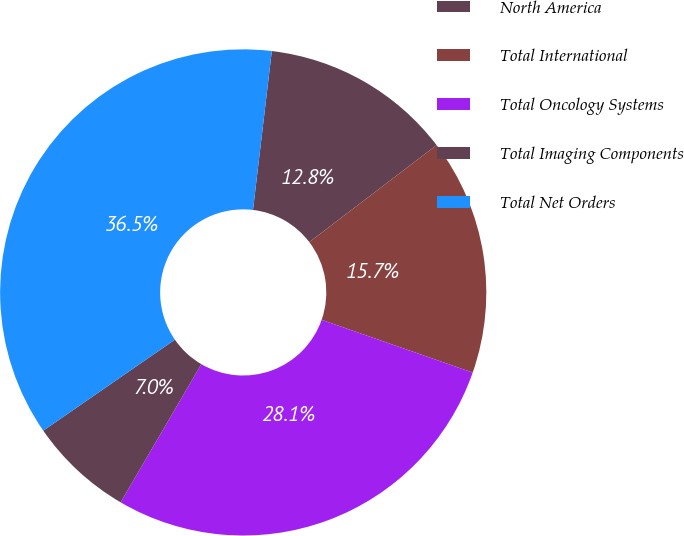<chart> <loc_0><loc_0><loc_500><loc_500><pie_chart><fcel>North America<fcel>Total International<fcel>Total Oncology Systems<fcel>Total Imaging Components<fcel>Total Net Orders<nl><fcel>12.76%<fcel>15.71%<fcel>28.06%<fcel>6.96%<fcel>36.5%<nl></chart> 